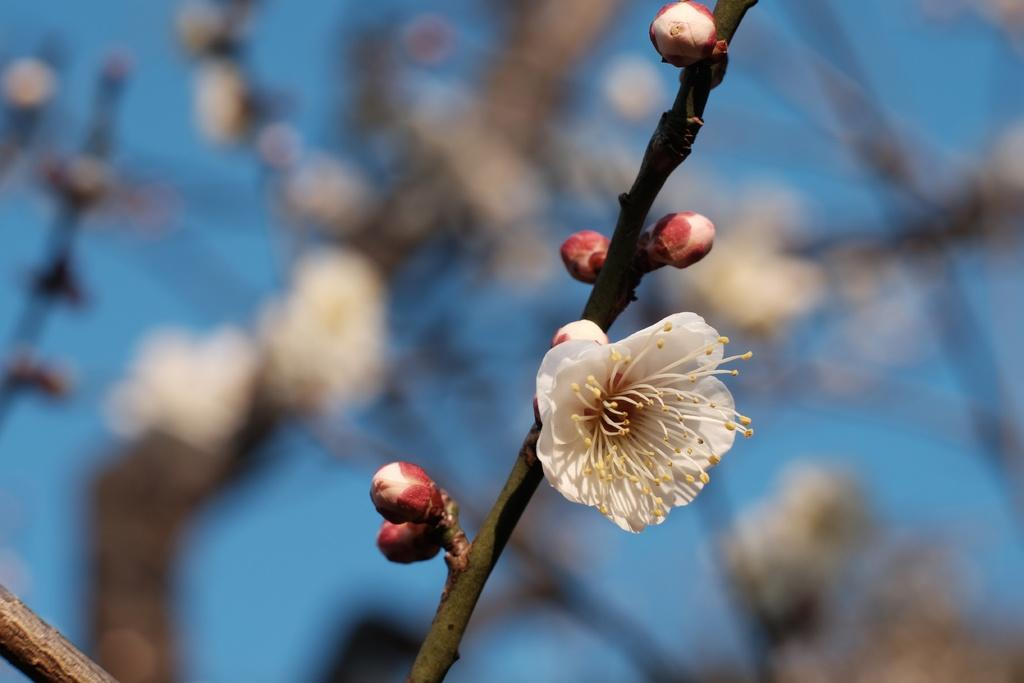What is the main subject of the image? The main subject of the image is a stem of a plant with a white flower. Can you describe the flower on the stem? Yes, there is a white color flower on the stem. What else can be seen in the background of the image? There are flowers in the background of the image. What color is the sky in the image? The sky is blue in the image. Can you hear the sound of thunder in the image? There is no sound present in the image, so it is not possible to hear thunder or any other sounds. 